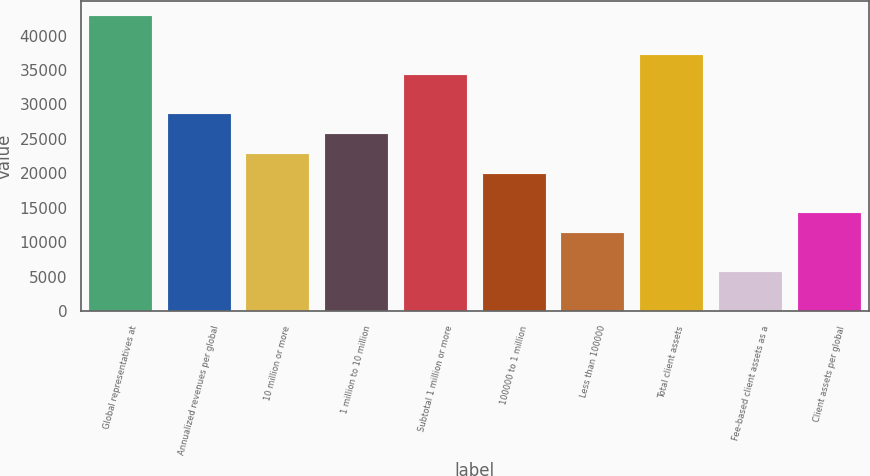Convert chart to OTSL. <chart><loc_0><loc_0><loc_500><loc_500><bar_chart><fcel>Global representatives at<fcel>Annualized revenues per global<fcel>10 million or more<fcel>1 million to 10 million<fcel>Subtotal 1 million or more<fcel>100000 to 1 million<fcel>Less than 100000<fcel>Total client assets<fcel>Fee-based client assets as a<fcel>Client assets per global<nl><fcel>42832.4<fcel>28555<fcel>22844<fcel>25699.5<fcel>34266<fcel>19988.5<fcel>11422<fcel>37121.4<fcel>5711.06<fcel>14277.5<nl></chart> 